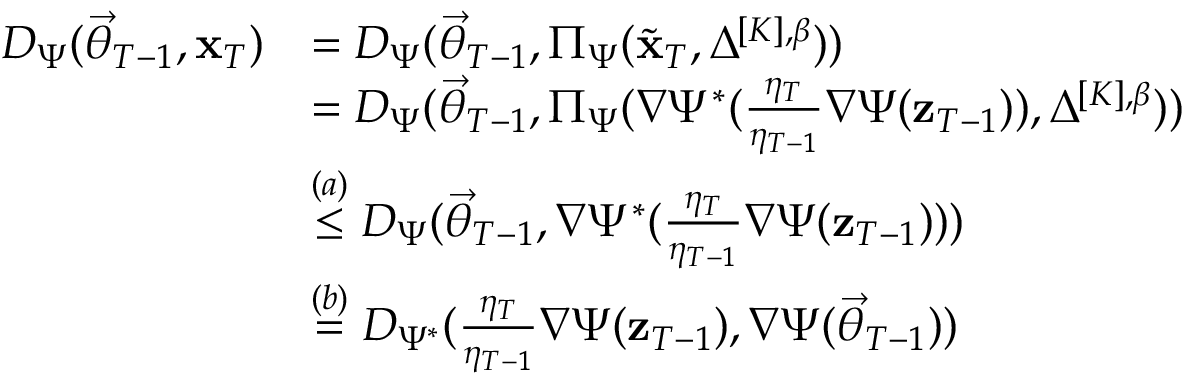Convert formula to latex. <formula><loc_0><loc_0><loc_500><loc_500>\begin{array} { r l } { D _ { \Psi } ( \vec { \theta } _ { T - 1 } , \mathbf x _ { T } ) } & { = D _ { \Psi } ( \vec { \theta } _ { T - 1 } , \Pi _ { \Psi } ( \widetilde { \mathbf x } _ { T } , \Delta ^ { [ K ] , \beta } ) ) } \\ & { = D _ { \Psi } ( \vec { \theta } _ { T - 1 } , \Pi _ { \Psi } ( \nabla \Psi ^ { * } ( \frac { \eta _ { T } } { \eta _ { T - 1 } } \nabla \Psi ( \mathbf z _ { T - 1 } ) ) , \Delta ^ { [ K ] , \beta } ) ) } \\ & { \stackrel { ( a ) } \leq D _ { \Psi } ( \vec { \theta } _ { T - 1 } , \nabla \Psi ^ { * } ( \frac { \eta _ { T } } { \eta _ { T - 1 } } \nabla \Psi ( \mathbf z _ { T - 1 } ) ) ) } \\ & { \stackrel { ( b ) } = D _ { \Psi ^ { * } } ( \frac { \eta _ { T } } { \eta _ { T - 1 } } \nabla \Psi ( \mathbf z _ { T - 1 } ) , \nabla \Psi ( \vec { \theta } _ { T - 1 } ) ) } \end{array}</formula> 